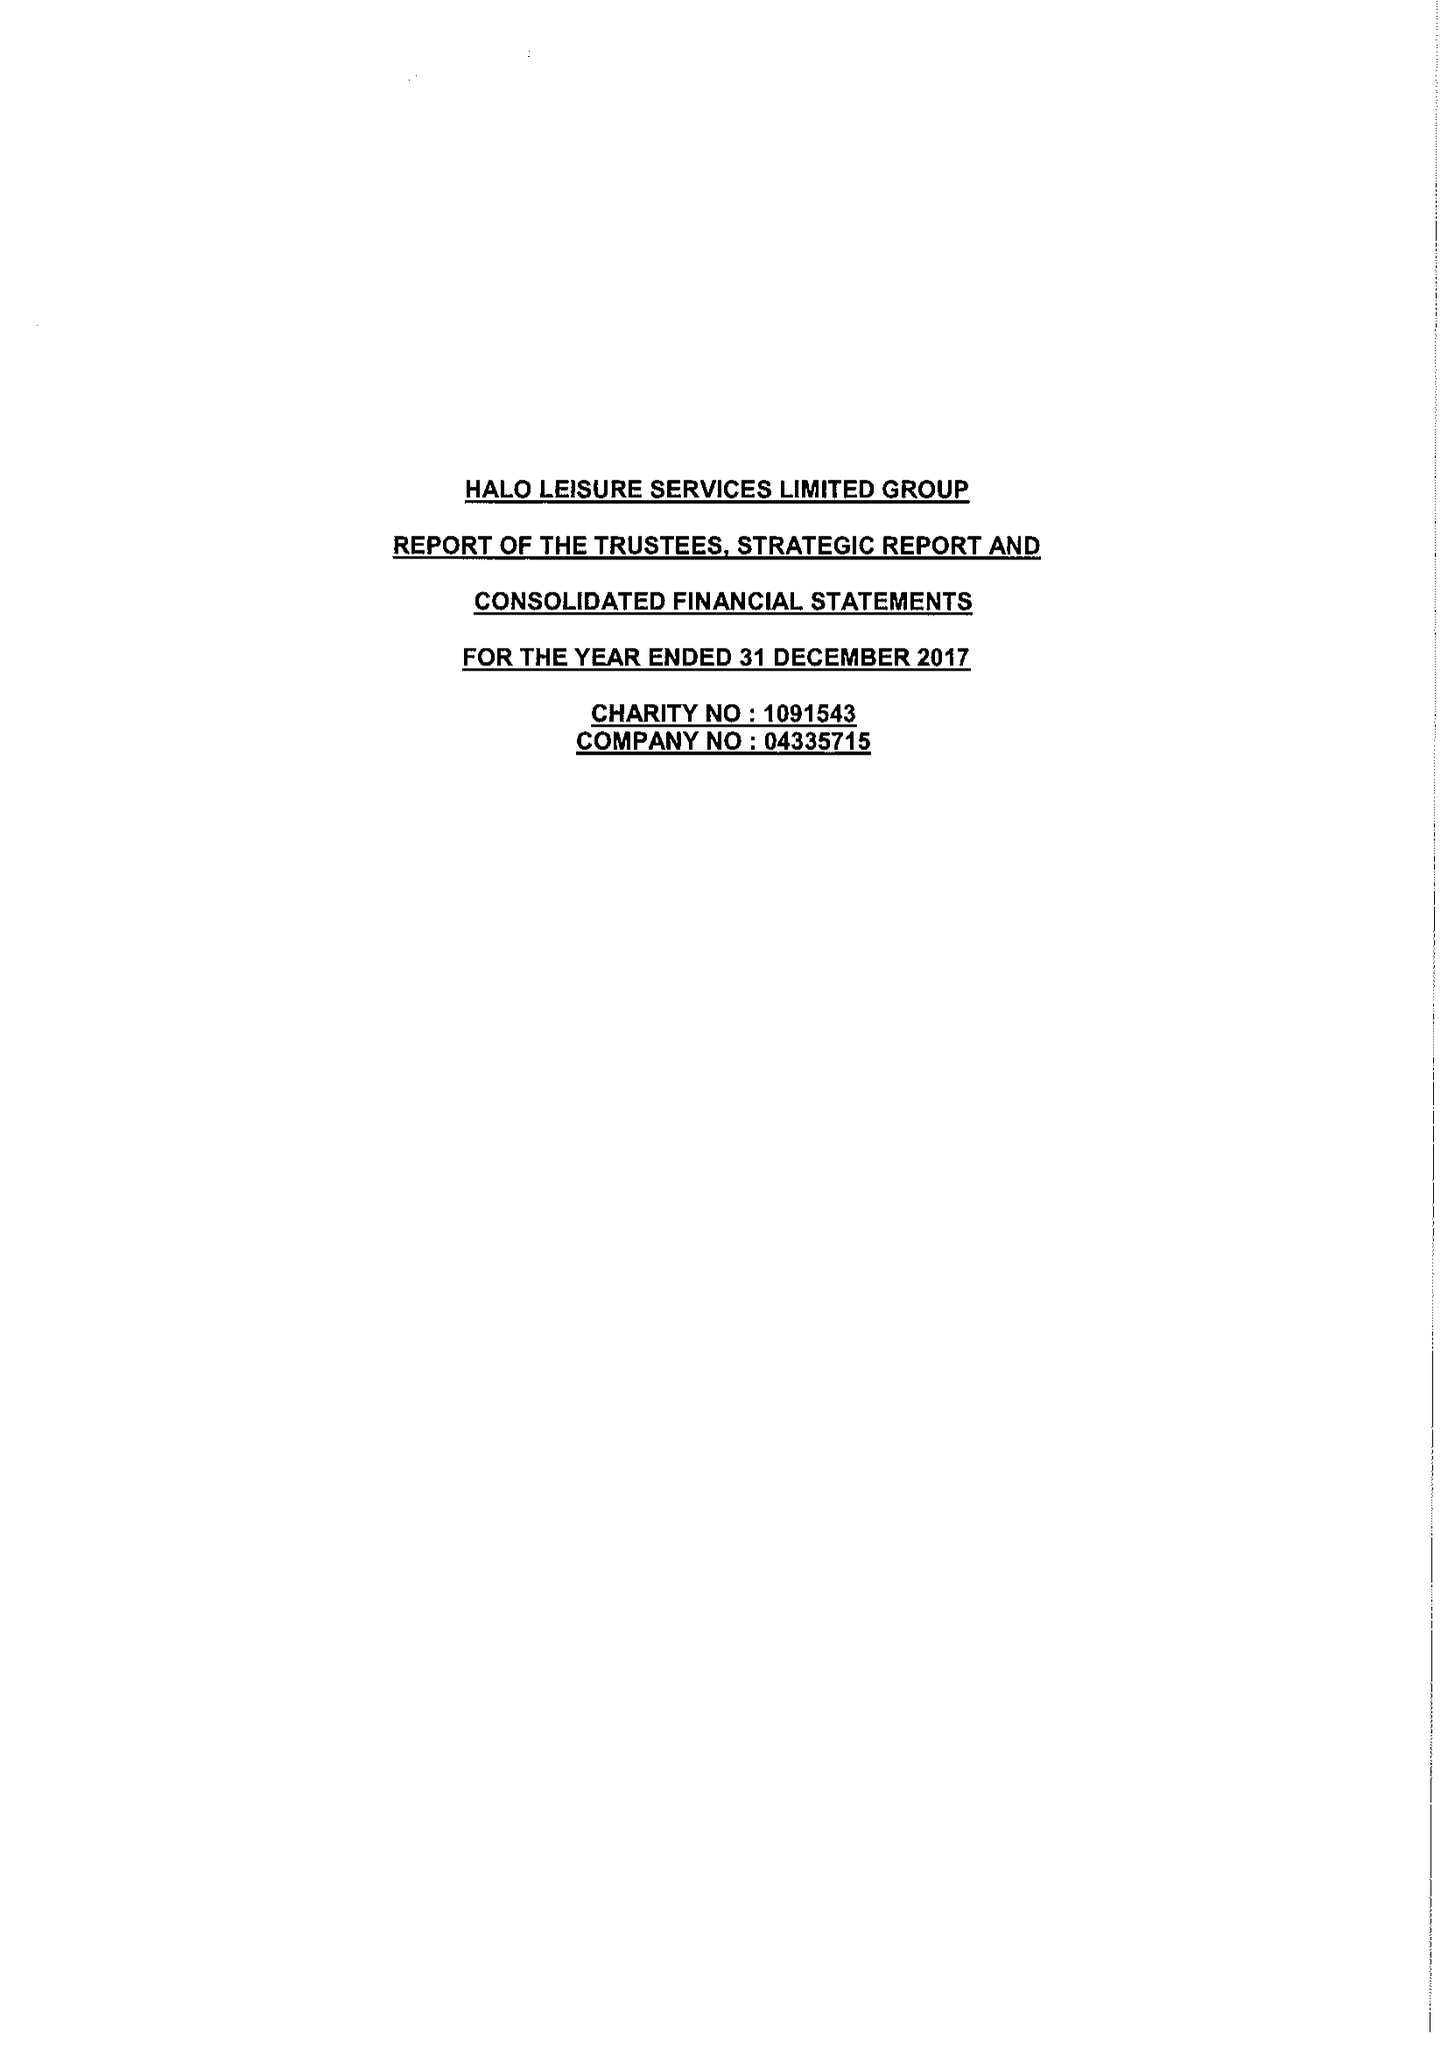What is the value for the address__post_town?
Answer the question using a single word or phrase. LEOMINSTER 